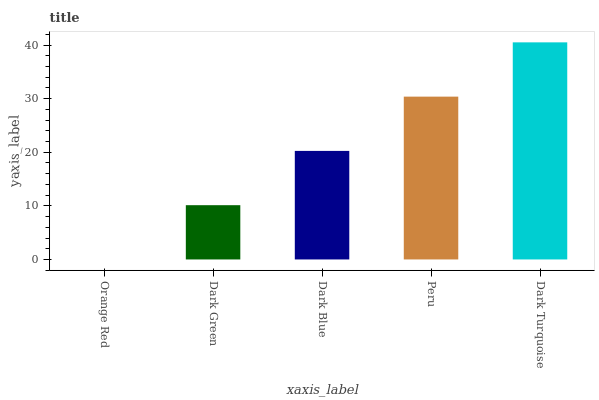Is Dark Green the minimum?
Answer yes or no. No. Is Dark Green the maximum?
Answer yes or no. No. Is Dark Green greater than Orange Red?
Answer yes or no. Yes. Is Orange Red less than Dark Green?
Answer yes or no. Yes. Is Orange Red greater than Dark Green?
Answer yes or no. No. Is Dark Green less than Orange Red?
Answer yes or no. No. Is Dark Blue the high median?
Answer yes or no. Yes. Is Dark Blue the low median?
Answer yes or no. Yes. Is Peru the high median?
Answer yes or no. No. Is Orange Red the low median?
Answer yes or no. No. 